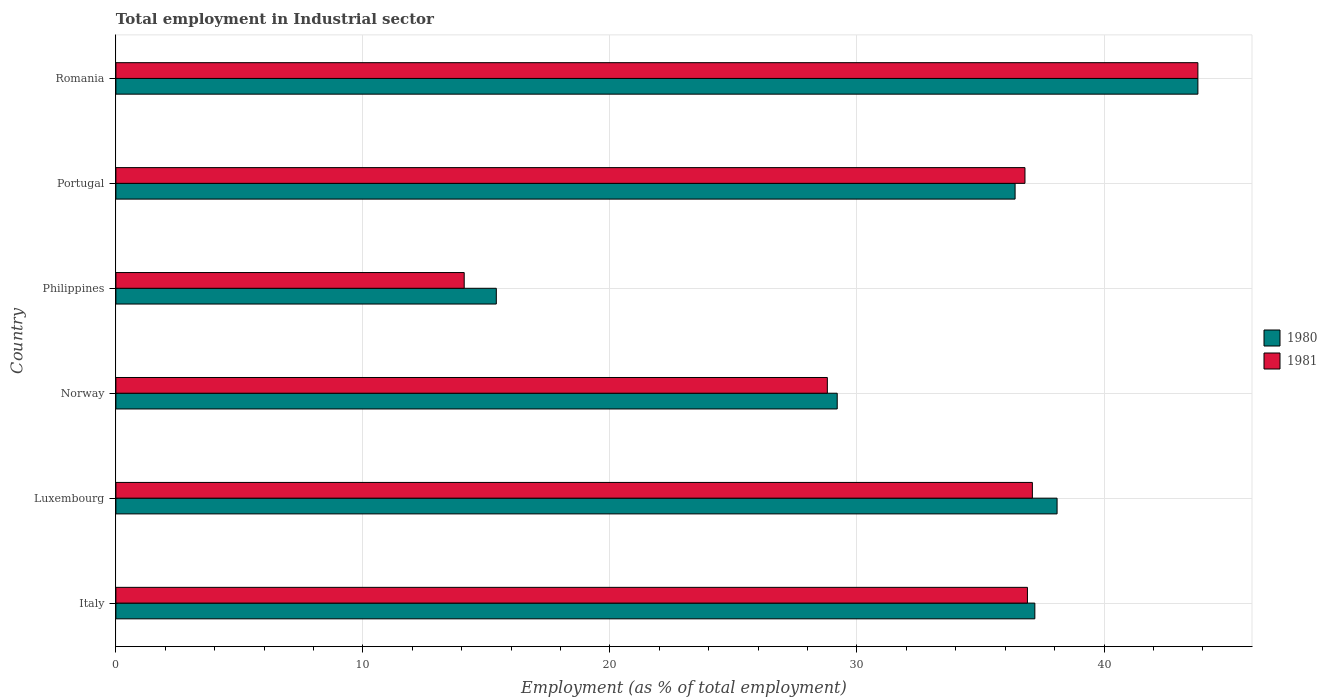How many groups of bars are there?
Give a very brief answer. 6. Are the number of bars per tick equal to the number of legend labels?
Your answer should be very brief. Yes. Are the number of bars on each tick of the Y-axis equal?
Your answer should be very brief. Yes. How many bars are there on the 2nd tick from the top?
Your answer should be very brief. 2. In how many cases, is the number of bars for a given country not equal to the number of legend labels?
Provide a short and direct response. 0. What is the employment in industrial sector in 1981 in Italy?
Provide a short and direct response. 36.9. Across all countries, what is the maximum employment in industrial sector in 1980?
Offer a terse response. 43.8. Across all countries, what is the minimum employment in industrial sector in 1980?
Ensure brevity in your answer.  15.4. In which country was the employment in industrial sector in 1981 maximum?
Give a very brief answer. Romania. What is the total employment in industrial sector in 1981 in the graph?
Your response must be concise. 197.5. What is the difference between the employment in industrial sector in 1980 in Philippines and that in Portugal?
Your answer should be compact. -21. What is the difference between the employment in industrial sector in 1980 in Luxembourg and the employment in industrial sector in 1981 in Portugal?
Make the answer very short. 1.3. What is the average employment in industrial sector in 1980 per country?
Ensure brevity in your answer.  33.35. What is the difference between the employment in industrial sector in 1980 and employment in industrial sector in 1981 in Norway?
Offer a very short reply. 0.4. What is the ratio of the employment in industrial sector in 1981 in Italy to that in Portugal?
Your answer should be compact. 1. Is the employment in industrial sector in 1980 in Norway less than that in Philippines?
Offer a terse response. No. Is the difference between the employment in industrial sector in 1980 in Italy and Luxembourg greater than the difference between the employment in industrial sector in 1981 in Italy and Luxembourg?
Provide a succinct answer. No. What is the difference between the highest and the second highest employment in industrial sector in 1981?
Make the answer very short. 6.7. What is the difference between the highest and the lowest employment in industrial sector in 1980?
Give a very brief answer. 28.4. Is the sum of the employment in industrial sector in 1981 in Luxembourg and Philippines greater than the maximum employment in industrial sector in 1980 across all countries?
Ensure brevity in your answer.  Yes. Are all the bars in the graph horizontal?
Offer a terse response. Yes. Are the values on the major ticks of X-axis written in scientific E-notation?
Offer a very short reply. No. Does the graph contain any zero values?
Offer a very short reply. No. Where does the legend appear in the graph?
Offer a terse response. Center right. How many legend labels are there?
Your answer should be very brief. 2. What is the title of the graph?
Give a very brief answer. Total employment in Industrial sector. What is the label or title of the X-axis?
Make the answer very short. Employment (as % of total employment). What is the label or title of the Y-axis?
Your answer should be compact. Country. What is the Employment (as % of total employment) in 1980 in Italy?
Offer a terse response. 37.2. What is the Employment (as % of total employment) in 1981 in Italy?
Make the answer very short. 36.9. What is the Employment (as % of total employment) of 1980 in Luxembourg?
Ensure brevity in your answer.  38.1. What is the Employment (as % of total employment) of 1981 in Luxembourg?
Your answer should be very brief. 37.1. What is the Employment (as % of total employment) of 1980 in Norway?
Provide a succinct answer. 29.2. What is the Employment (as % of total employment) in 1981 in Norway?
Keep it short and to the point. 28.8. What is the Employment (as % of total employment) in 1980 in Philippines?
Your answer should be very brief. 15.4. What is the Employment (as % of total employment) in 1981 in Philippines?
Your answer should be very brief. 14.1. What is the Employment (as % of total employment) of 1980 in Portugal?
Ensure brevity in your answer.  36.4. What is the Employment (as % of total employment) in 1981 in Portugal?
Keep it short and to the point. 36.8. What is the Employment (as % of total employment) of 1980 in Romania?
Your answer should be compact. 43.8. What is the Employment (as % of total employment) of 1981 in Romania?
Your answer should be compact. 43.8. Across all countries, what is the maximum Employment (as % of total employment) in 1980?
Provide a succinct answer. 43.8. Across all countries, what is the maximum Employment (as % of total employment) in 1981?
Offer a terse response. 43.8. Across all countries, what is the minimum Employment (as % of total employment) in 1980?
Give a very brief answer. 15.4. Across all countries, what is the minimum Employment (as % of total employment) of 1981?
Ensure brevity in your answer.  14.1. What is the total Employment (as % of total employment) in 1980 in the graph?
Ensure brevity in your answer.  200.1. What is the total Employment (as % of total employment) of 1981 in the graph?
Provide a succinct answer. 197.5. What is the difference between the Employment (as % of total employment) of 1980 in Italy and that in Philippines?
Provide a short and direct response. 21.8. What is the difference between the Employment (as % of total employment) in 1981 in Italy and that in Philippines?
Your answer should be very brief. 22.8. What is the difference between the Employment (as % of total employment) in 1980 in Italy and that in Portugal?
Your answer should be very brief. 0.8. What is the difference between the Employment (as % of total employment) in 1981 in Italy and that in Portugal?
Provide a succinct answer. 0.1. What is the difference between the Employment (as % of total employment) of 1980 in Luxembourg and that in Norway?
Your answer should be compact. 8.9. What is the difference between the Employment (as % of total employment) of 1980 in Luxembourg and that in Philippines?
Provide a succinct answer. 22.7. What is the difference between the Employment (as % of total employment) in 1980 in Luxembourg and that in Portugal?
Your answer should be compact. 1.7. What is the difference between the Employment (as % of total employment) of 1981 in Luxembourg and that in Portugal?
Give a very brief answer. 0.3. What is the difference between the Employment (as % of total employment) of 1980 in Norway and that in Portugal?
Your answer should be very brief. -7.2. What is the difference between the Employment (as % of total employment) of 1981 in Norway and that in Portugal?
Provide a short and direct response. -8. What is the difference between the Employment (as % of total employment) of 1980 in Norway and that in Romania?
Offer a terse response. -14.6. What is the difference between the Employment (as % of total employment) in 1981 in Norway and that in Romania?
Your response must be concise. -15. What is the difference between the Employment (as % of total employment) of 1981 in Philippines and that in Portugal?
Your response must be concise. -22.7. What is the difference between the Employment (as % of total employment) in 1980 in Philippines and that in Romania?
Your answer should be very brief. -28.4. What is the difference between the Employment (as % of total employment) in 1981 in Philippines and that in Romania?
Your answer should be compact. -29.7. What is the difference between the Employment (as % of total employment) of 1980 in Portugal and that in Romania?
Keep it short and to the point. -7.4. What is the difference between the Employment (as % of total employment) of 1980 in Italy and the Employment (as % of total employment) of 1981 in Luxembourg?
Offer a very short reply. 0.1. What is the difference between the Employment (as % of total employment) in 1980 in Italy and the Employment (as % of total employment) in 1981 in Philippines?
Give a very brief answer. 23.1. What is the difference between the Employment (as % of total employment) of 1980 in Italy and the Employment (as % of total employment) of 1981 in Romania?
Ensure brevity in your answer.  -6.6. What is the difference between the Employment (as % of total employment) of 1980 in Luxembourg and the Employment (as % of total employment) of 1981 in Norway?
Make the answer very short. 9.3. What is the difference between the Employment (as % of total employment) of 1980 in Luxembourg and the Employment (as % of total employment) of 1981 in Portugal?
Make the answer very short. 1.3. What is the difference between the Employment (as % of total employment) in 1980 in Norway and the Employment (as % of total employment) in 1981 in Philippines?
Make the answer very short. 15.1. What is the difference between the Employment (as % of total employment) in 1980 in Norway and the Employment (as % of total employment) in 1981 in Romania?
Make the answer very short. -14.6. What is the difference between the Employment (as % of total employment) of 1980 in Philippines and the Employment (as % of total employment) of 1981 in Portugal?
Ensure brevity in your answer.  -21.4. What is the difference between the Employment (as % of total employment) in 1980 in Philippines and the Employment (as % of total employment) in 1981 in Romania?
Keep it short and to the point. -28.4. What is the average Employment (as % of total employment) in 1980 per country?
Make the answer very short. 33.35. What is the average Employment (as % of total employment) of 1981 per country?
Give a very brief answer. 32.92. What is the difference between the Employment (as % of total employment) of 1980 and Employment (as % of total employment) of 1981 in Luxembourg?
Provide a short and direct response. 1. What is the difference between the Employment (as % of total employment) of 1980 and Employment (as % of total employment) of 1981 in Norway?
Your response must be concise. 0.4. What is the difference between the Employment (as % of total employment) of 1980 and Employment (as % of total employment) of 1981 in Romania?
Provide a short and direct response. 0. What is the ratio of the Employment (as % of total employment) in 1980 in Italy to that in Luxembourg?
Give a very brief answer. 0.98. What is the ratio of the Employment (as % of total employment) in 1980 in Italy to that in Norway?
Offer a terse response. 1.27. What is the ratio of the Employment (as % of total employment) in 1981 in Italy to that in Norway?
Keep it short and to the point. 1.28. What is the ratio of the Employment (as % of total employment) in 1980 in Italy to that in Philippines?
Your answer should be compact. 2.42. What is the ratio of the Employment (as % of total employment) of 1981 in Italy to that in Philippines?
Ensure brevity in your answer.  2.62. What is the ratio of the Employment (as % of total employment) of 1980 in Italy to that in Romania?
Offer a terse response. 0.85. What is the ratio of the Employment (as % of total employment) in 1981 in Italy to that in Romania?
Keep it short and to the point. 0.84. What is the ratio of the Employment (as % of total employment) in 1980 in Luxembourg to that in Norway?
Provide a short and direct response. 1.3. What is the ratio of the Employment (as % of total employment) in 1981 in Luxembourg to that in Norway?
Offer a terse response. 1.29. What is the ratio of the Employment (as % of total employment) in 1980 in Luxembourg to that in Philippines?
Keep it short and to the point. 2.47. What is the ratio of the Employment (as % of total employment) in 1981 in Luxembourg to that in Philippines?
Your answer should be very brief. 2.63. What is the ratio of the Employment (as % of total employment) in 1980 in Luxembourg to that in Portugal?
Your answer should be very brief. 1.05. What is the ratio of the Employment (as % of total employment) of 1981 in Luxembourg to that in Portugal?
Your answer should be compact. 1.01. What is the ratio of the Employment (as % of total employment) in 1980 in Luxembourg to that in Romania?
Provide a short and direct response. 0.87. What is the ratio of the Employment (as % of total employment) of 1981 in Luxembourg to that in Romania?
Offer a terse response. 0.85. What is the ratio of the Employment (as % of total employment) in 1980 in Norway to that in Philippines?
Keep it short and to the point. 1.9. What is the ratio of the Employment (as % of total employment) in 1981 in Norway to that in Philippines?
Provide a short and direct response. 2.04. What is the ratio of the Employment (as % of total employment) of 1980 in Norway to that in Portugal?
Keep it short and to the point. 0.8. What is the ratio of the Employment (as % of total employment) in 1981 in Norway to that in Portugal?
Offer a terse response. 0.78. What is the ratio of the Employment (as % of total employment) in 1980 in Norway to that in Romania?
Make the answer very short. 0.67. What is the ratio of the Employment (as % of total employment) of 1981 in Norway to that in Romania?
Make the answer very short. 0.66. What is the ratio of the Employment (as % of total employment) of 1980 in Philippines to that in Portugal?
Provide a succinct answer. 0.42. What is the ratio of the Employment (as % of total employment) in 1981 in Philippines to that in Portugal?
Your answer should be compact. 0.38. What is the ratio of the Employment (as % of total employment) in 1980 in Philippines to that in Romania?
Make the answer very short. 0.35. What is the ratio of the Employment (as % of total employment) of 1981 in Philippines to that in Romania?
Offer a very short reply. 0.32. What is the ratio of the Employment (as % of total employment) in 1980 in Portugal to that in Romania?
Your answer should be compact. 0.83. What is the ratio of the Employment (as % of total employment) in 1981 in Portugal to that in Romania?
Give a very brief answer. 0.84. What is the difference between the highest and the second highest Employment (as % of total employment) of 1981?
Keep it short and to the point. 6.7. What is the difference between the highest and the lowest Employment (as % of total employment) in 1980?
Your answer should be compact. 28.4. What is the difference between the highest and the lowest Employment (as % of total employment) of 1981?
Give a very brief answer. 29.7. 